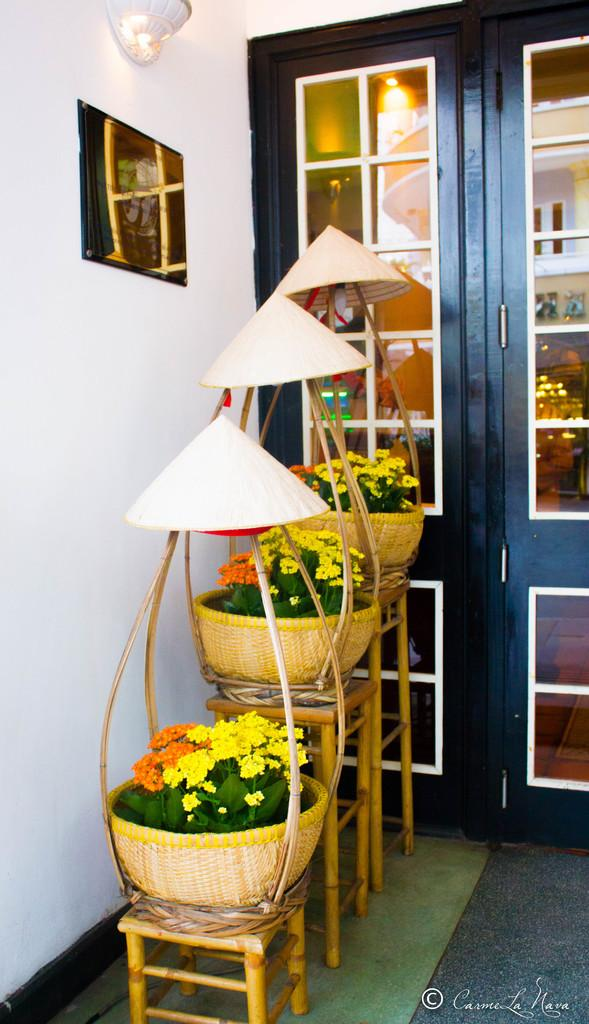What is in the basket that is visible in the image? There are plants with flowers in a basket. How is the basket supported in the image? The basket is placed on stools. What can be seen in the image that might indicate an entrance or exit? There is a door in the image. What type of decorative item is present in the image? There is a photo frame in the image. What change has been made to the lighting in the room? A ceiling light has been changed to a wall light. How many hands are visible in the image? There are no hands visible in the image. What type of ducks can be seen swimming in the basket? There are no ducks present in the image; it features a basket of plants with flowers. 